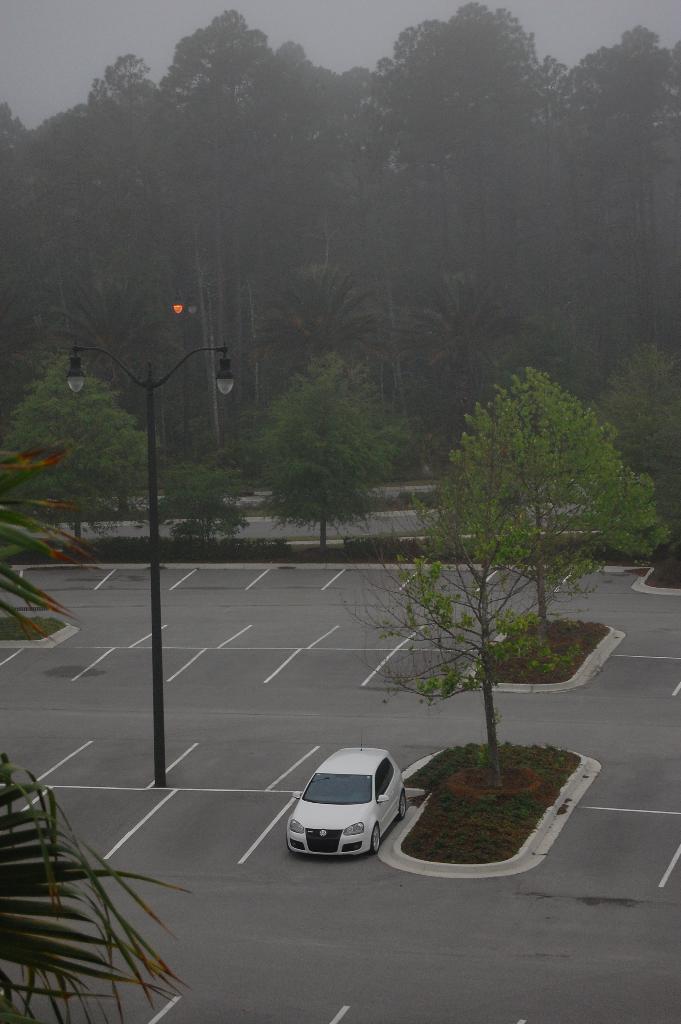Could you give a brief overview of what you see in this image? In this image I can see trees,light-poles and white color car on road. 